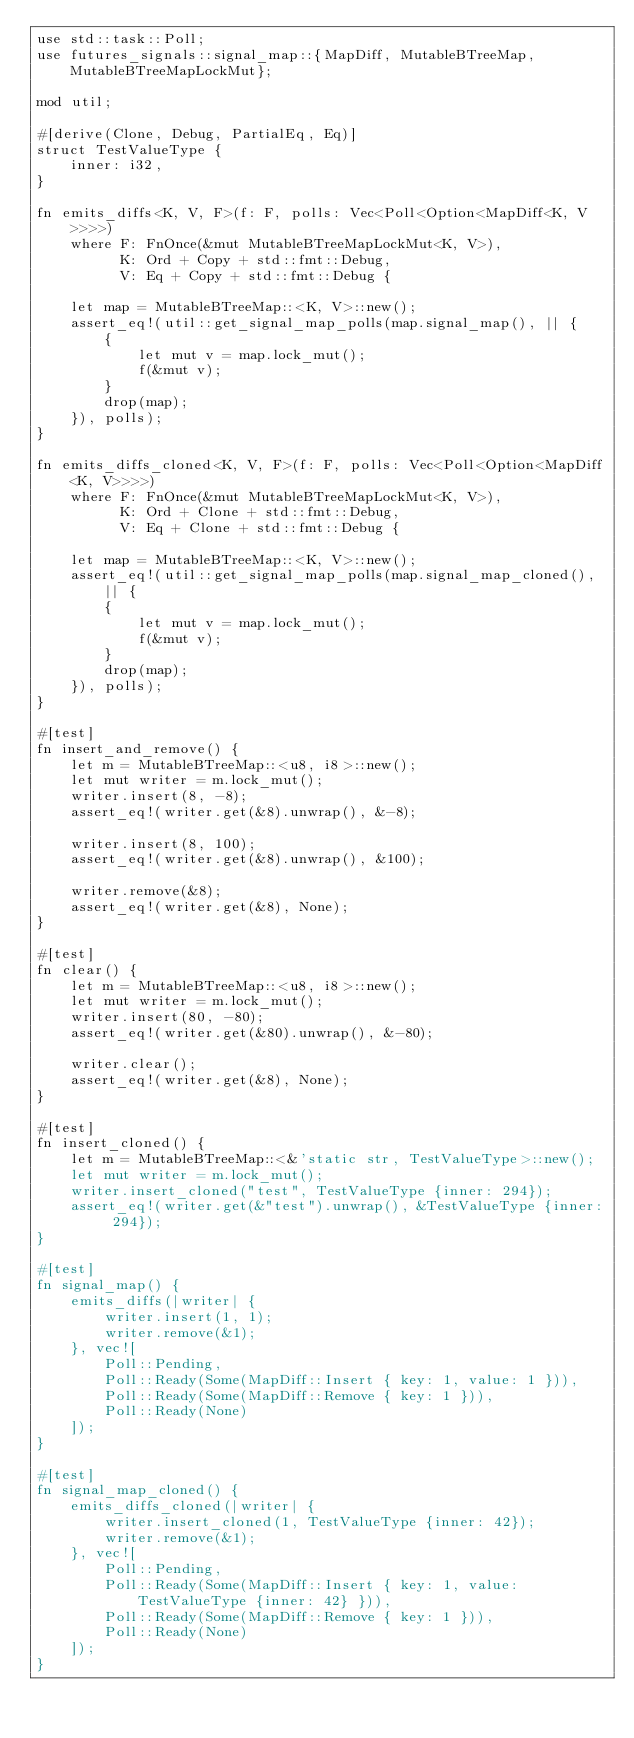<code> <loc_0><loc_0><loc_500><loc_500><_Rust_>use std::task::Poll;
use futures_signals::signal_map::{MapDiff, MutableBTreeMap, MutableBTreeMapLockMut};

mod util;

#[derive(Clone, Debug, PartialEq, Eq)]
struct TestValueType {
    inner: i32,
}

fn emits_diffs<K, V, F>(f: F, polls: Vec<Poll<Option<MapDiff<K, V>>>>)
    where F: FnOnce(&mut MutableBTreeMapLockMut<K, V>), 
          K: Ord + Copy + std::fmt::Debug,
          V: Eq + Copy + std::fmt::Debug {

    let map = MutableBTreeMap::<K, V>::new();
    assert_eq!(util::get_signal_map_polls(map.signal_map(), || {
        {
            let mut v = map.lock_mut();
            f(&mut v);
        }
        drop(map);
    }), polls);
}

fn emits_diffs_cloned<K, V, F>(f: F, polls: Vec<Poll<Option<MapDiff<K, V>>>>)
    where F: FnOnce(&mut MutableBTreeMapLockMut<K, V>), 
          K: Ord + Clone + std::fmt::Debug,
          V: Eq + Clone + std::fmt::Debug {

    let map = MutableBTreeMap::<K, V>::new();
    assert_eq!(util::get_signal_map_polls(map.signal_map_cloned(), || {
        {
            let mut v = map.lock_mut();
            f(&mut v);
        }
        drop(map);
    }), polls);
}

#[test]
fn insert_and_remove() {
    let m = MutableBTreeMap::<u8, i8>::new();
    let mut writer = m.lock_mut();
    writer.insert(8, -8);
    assert_eq!(writer.get(&8).unwrap(), &-8);

    writer.insert(8, 100);
    assert_eq!(writer.get(&8).unwrap(), &100);

    writer.remove(&8);
    assert_eq!(writer.get(&8), None);
}

#[test]
fn clear() {
    let m = MutableBTreeMap::<u8, i8>::new();
    let mut writer = m.lock_mut();
    writer.insert(80, -80);
    assert_eq!(writer.get(&80).unwrap(), &-80);

    writer.clear();
    assert_eq!(writer.get(&8), None);
}

#[test]
fn insert_cloned() {
    let m = MutableBTreeMap::<&'static str, TestValueType>::new();
    let mut writer = m.lock_mut();
    writer.insert_cloned("test", TestValueType {inner: 294});
    assert_eq!(writer.get(&"test").unwrap(), &TestValueType {inner: 294});
}

#[test]
fn signal_map() {
    emits_diffs(|writer| {
        writer.insert(1, 1);
        writer.remove(&1);
    }, vec![
        Poll::Pending, 
        Poll::Ready(Some(MapDiff::Insert { key: 1, value: 1 })),
        Poll::Ready(Some(MapDiff::Remove { key: 1 })),
        Poll::Ready(None)
    ]);
}

#[test]
fn signal_map_cloned() {
    emits_diffs_cloned(|writer| {
        writer.insert_cloned(1, TestValueType {inner: 42});
        writer.remove(&1);
    }, vec![
        Poll::Pending, 
        Poll::Ready(Some(MapDiff::Insert { key: 1, value: TestValueType {inner: 42} })),
        Poll::Ready(Some(MapDiff::Remove { key: 1 })),
        Poll::Ready(None)
    ]);
}</code> 